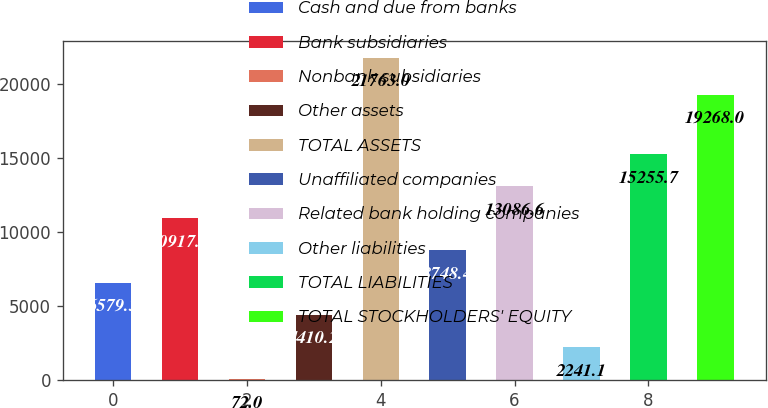<chart> <loc_0><loc_0><loc_500><loc_500><bar_chart><fcel>Cash and due from banks<fcel>Bank subsidiaries<fcel>Nonbank subsidiaries<fcel>Other assets<fcel>TOTAL ASSETS<fcel>Unaffiliated companies<fcel>Related bank holding companies<fcel>Other liabilities<fcel>TOTAL LIABILITIES<fcel>TOTAL STOCKHOLDERS' EQUITY<nl><fcel>6579.3<fcel>10917.5<fcel>72<fcel>4410.2<fcel>21763<fcel>8748.4<fcel>13086.6<fcel>2241.1<fcel>15255.7<fcel>19268<nl></chart> 